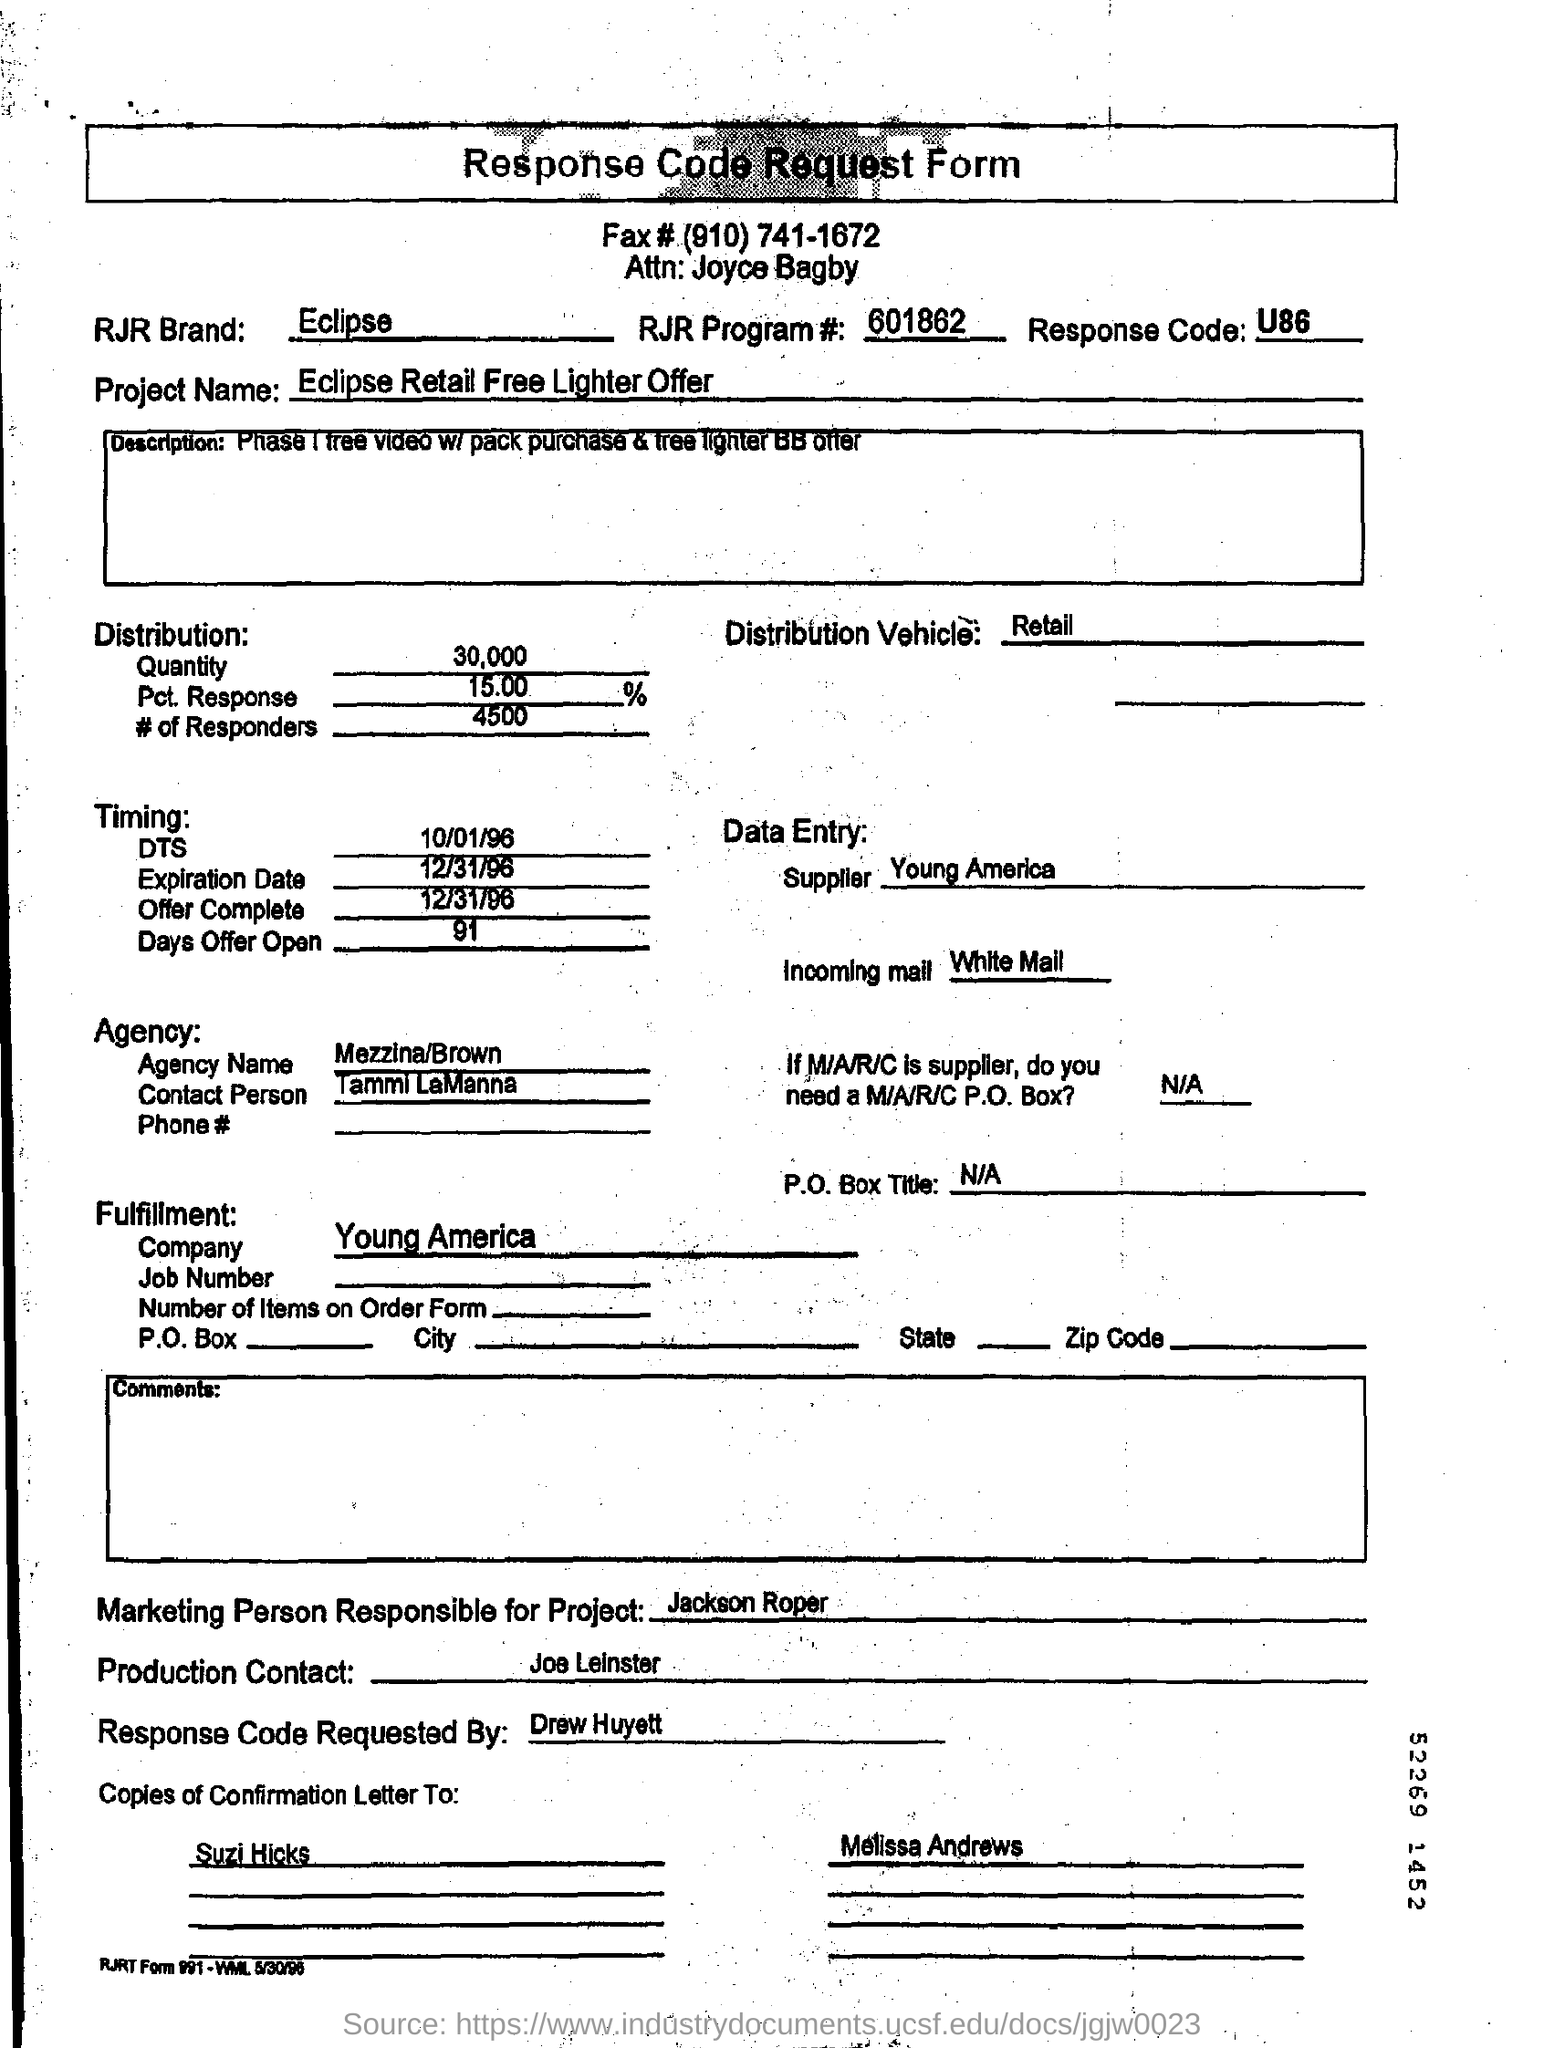Give some essential details in this illustration. What is the DTS? This date is October 1, 1996. The supplier is Young America. The RJR Brand is known for its Eclipse cigarette brand, which is known for its distinctive packaging and advertising campaigns. 30,000.. is the quantity. The expiration date is December 31, 1996. 